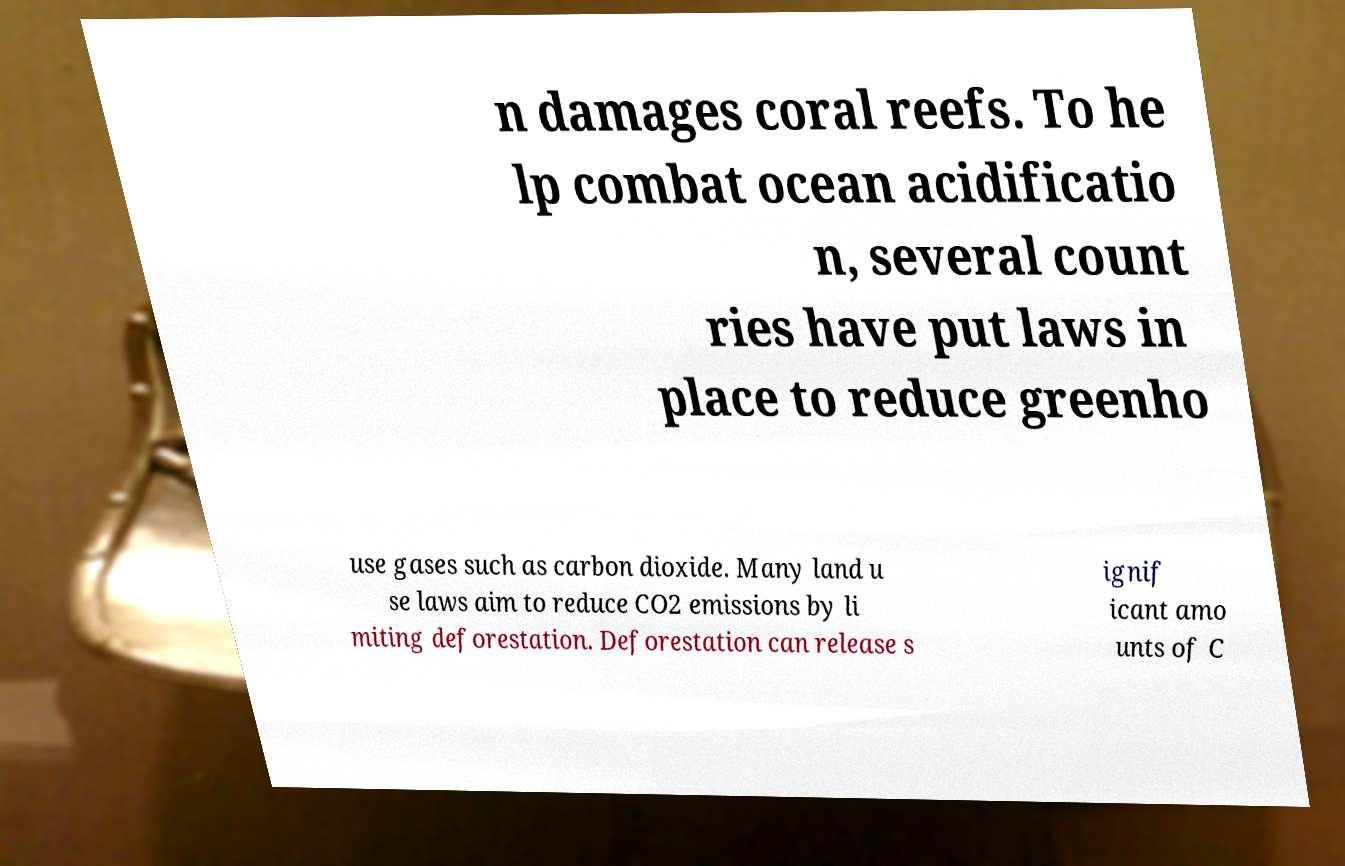What messages or text are displayed in this image? I need them in a readable, typed format. n damages coral reefs. To he lp combat ocean acidificatio n, several count ries have put laws in place to reduce greenho use gases such as carbon dioxide. Many land u se laws aim to reduce CO2 emissions by li miting deforestation. Deforestation can release s ignif icant amo unts of C 